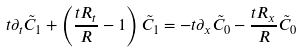Convert formula to latex. <formula><loc_0><loc_0><loc_500><loc_500>t \partial _ { t } \tilde { C } _ { 1 } + \left ( \frac { t R _ { t } } { R } - 1 \right ) \tilde { C } _ { 1 } = - t \partial _ { x } \tilde { C } _ { 0 } - \frac { t R _ { x } } { R } \tilde { C } _ { 0 }</formula> 